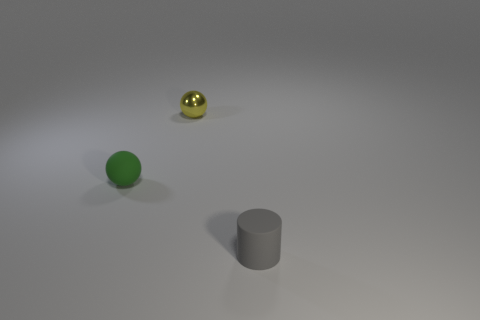Are there more tiny gray things than yellow matte cubes?
Your answer should be compact. Yes. What material is the small yellow thing that is the same shape as the green matte object?
Keep it short and to the point. Metal. Is the gray thing made of the same material as the yellow ball?
Your response must be concise. No. Is the number of metal objects behind the tiny gray cylinder greater than the number of yellow shiny balls?
Keep it short and to the point. No. What is the material of the small object behind the tiny matte object behind the object that is in front of the green thing?
Your response must be concise. Metal. How many objects are metallic balls or rubber things that are left of the small cylinder?
Your response must be concise. 2. Do the ball left of the tiny metallic sphere and the tiny metal ball have the same color?
Make the answer very short. No. Is the number of small yellow spheres that are behind the gray rubber cylinder greater than the number of small balls that are right of the yellow thing?
Make the answer very short. Yes. Is there anything else of the same color as the tiny metal ball?
Give a very brief answer. No. How many objects are gray rubber objects or yellow metallic cylinders?
Keep it short and to the point. 1. 